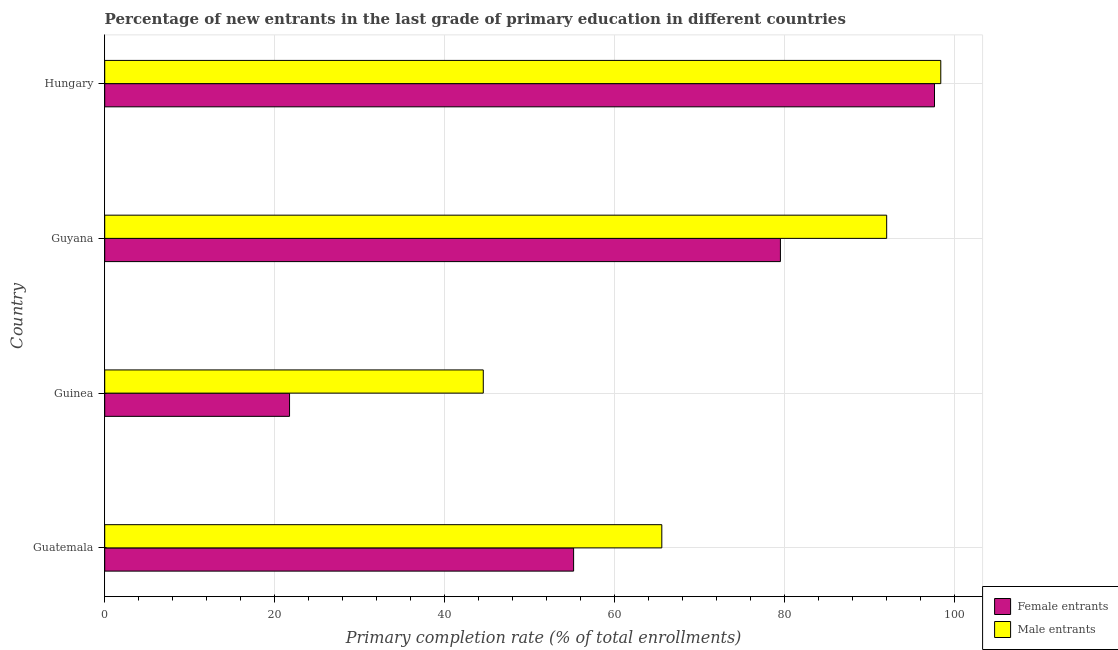How many different coloured bars are there?
Your answer should be compact. 2. Are the number of bars per tick equal to the number of legend labels?
Ensure brevity in your answer.  Yes. What is the label of the 1st group of bars from the top?
Ensure brevity in your answer.  Hungary. In how many cases, is the number of bars for a given country not equal to the number of legend labels?
Offer a very short reply. 0. What is the primary completion rate of female entrants in Guinea?
Your response must be concise. 21.75. Across all countries, what is the maximum primary completion rate of male entrants?
Offer a very short reply. 98.41. Across all countries, what is the minimum primary completion rate of female entrants?
Provide a short and direct response. 21.75. In which country was the primary completion rate of female entrants maximum?
Ensure brevity in your answer.  Hungary. In which country was the primary completion rate of male entrants minimum?
Make the answer very short. Guinea. What is the total primary completion rate of male entrants in the graph?
Offer a very short reply. 300.58. What is the difference between the primary completion rate of female entrants in Guatemala and that in Guinea?
Your answer should be very brief. 33.44. What is the difference between the primary completion rate of female entrants in Guatemala and the primary completion rate of male entrants in Guyana?
Make the answer very short. -36.85. What is the average primary completion rate of female entrants per country?
Offer a terse response. 63.54. What is the difference between the primary completion rate of male entrants and primary completion rate of female entrants in Hungary?
Provide a succinct answer. 0.74. What is the ratio of the primary completion rate of male entrants in Guinea to that in Hungary?
Give a very brief answer. 0.45. Is the difference between the primary completion rate of male entrants in Guyana and Hungary greater than the difference between the primary completion rate of female entrants in Guyana and Hungary?
Your answer should be compact. Yes. What is the difference between the highest and the second highest primary completion rate of male entrants?
Provide a succinct answer. 6.37. What is the difference between the highest and the lowest primary completion rate of male entrants?
Provide a succinct answer. 53.85. In how many countries, is the primary completion rate of female entrants greater than the average primary completion rate of female entrants taken over all countries?
Provide a short and direct response. 2. What does the 2nd bar from the top in Hungary represents?
Your answer should be compact. Female entrants. What does the 2nd bar from the bottom in Guyana represents?
Your answer should be very brief. Male entrants. What is the difference between two consecutive major ticks on the X-axis?
Provide a succinct answer. 20. Does the graph contain grids?
Offer a terse response. Yes. Where does the legend appear in the graph?
Give a very brief answer. Bottom right. How are the legend labels stacked?
Your response must be concise. Vertical. What is the title of the graph?
Offer a terse response. Percentage of new entrants in the last grade of primary education in different countries. Does "Attending school" appear as one of the legend labels in the graph?
Your response must be concise. No. What is the label or title of the X-axis?
Offer a very short reply. Primary completion rate (% of total enrollments). What is the Primary completion rate (% of total enrollments) of Female entrants in Guatemala?
Keep it short and to the point. 55.19. What is the Primary completion rate (% of total enrollments) of Male entrants in Guatemala?
Ensure brevity in your answer.  65.57. What is the Primary completion rate (% of total enrollments) in Female entrants in Guinea?
Provide a short and direct response. 21.75. What is the Primary completion rate (% of total enrollments) in Male entrants in Guinea?
Your answer should be compact. 44.56. What is the Primary completion rate (% of total enrollments) of Female entrants in Guyana?
Give a very brief answer. 79.53. What is the Primary completion rate (% of total enrollments) in Male entrants in Guyana?
Your answer should be compact. 92.04. What is the Primary completion rate (% of total enrollments) in Female entrants in Hungary?
Offer a terse response. 97.67. What is the Primary completion rate (% of total enrollments) in Male entrants in Hungary?
Offer a very short reply. 98.41. Across all countries, what is the maximum Primary completion rate (% of total enrollments) of Female entrants?
Your answer should be compact. 97.67. Across all countries, what is the maximum Primary completion rate (% of total enrollments) in Male entrants?
Provide a short and direct response. 98.41. Across all countries, what is the minimum Primary completion rate (% of total enrollments) in Female entrants?
Offer a terse response. 21.75. Across all countries, what is the minimum Primary completion rate (% of total enrollments) in Male entrants?
Offer a very short reply. 44.56. What is the total Primary completion rate (% of total enrollments) of Female entrants in the graph?
Provide a succinct answer. 254.15. What is the total Primary completion rate (% of total enrollments) of Male entrants in the graph?
Offer a terse response. 300.58. What is the difference between the Primary completion rate (% of total enrollments) of Female entrants in Guatemala and that in Guinea?
Your response must be concise. 33.44. What is the difference between the Primary completion rate (% of total enrollments) of Male entrants in Guatemala and that in Guinea?
Offer a terse response. 21.01. What is the difference between the Primary completion rate (% of total enrollments) in Female entrants in Guatemala and that in Guyana?
Your response must be concise. -24.34. What is the difference between the Primary completion rate (% of total enrollments) of Male entrants in Guatemala and that in Guyana?
Provide a short and direct response. -26.47. What is the difference between the Primary completion rate (% of total enrollments) in Female entrants in Guatemala and that in Hungary?
Offer a terse response. -42.48. What is the difference between the Primary completion rate (% of total enrollments) in Male entrants in Guatemala and that in Hungary?
Offer a very short reply. -32.84. What is the difference between the Primary completion rate (% of total enrollments) in Female entrants in Guinea and that in Guyana?
Offer a terse response. -57.78. What is the difference between the Primary completion rate (% of total enrollments) of Male entrants in Guinea and that in Guyana?
Offer a very short reply. -47.48. What is the difference between the Primary completion rate (% of total enrollments) of Female entrants in Guinea and that in Hungary?
Provide a short and direct response. -75.91. What is the difference between the Primary completion rate (% of total enrollments) in Male entrants in Guinea and that in Hungary?
Ensure brevity in your answer.  -53.85. What is the difference between the Primary completion rate (% of total enrollments) of Female entrants in Guyana and that in Hungary?
Offer a terse response. -18.14. What is the difference between the Primary completion rate (% of total enrollments) in Male entrants in Guyana and that in Hungary?
Your answer should be very brief. -6.37. What is the difference between the Primary completion rate (% of total enrollments) in Female entrants in Guatemala and the Primary completion rate (% of total enrollments) in Male entrants in Guinea?
Ensure brevity in your answer.  10.63. What is the difference between the Primary completion rate (% of total enrollments) of Female entrants in Guatemala and the Primary completion rate (% of total enrollments) of Male entrants in Guyana?
Your answer should be compact. -36.85. What is the difference between the Primary completion rate (% of total enrollments) in Female entrants in Guatemala and the Primary completion rate (% of total enrollments) in Male entrants in Hungary?
Your answer should be very brief. -43.22. What is the difference between the Primary completion rate (% of total enrollments) of Female entrants in Guinea and the Primary completion rate (% of total enrollments) of Male entrants in Guyana?
Provide a succinct answer. -70.29. What is the difference between the Primary completion rate (% of total enrollments) of Female entrants in Guinea and the Primary completion rate (% of total enrollments) of Male entrants in Hungary?
Give a very brief answer. -76.65. What is the difference between the Primary completion rate (% of total enrollments) in Female entrants in Guyana and the Primary completion rate (% of total enrollments) in Male entrants in Hungary?
Provide a short and direct response. -18.88. What is the average Primary completion rate (% of total enrollments) in Female entrants per country?
Give a very brief answer. 63.54. What is the average Primary completion rate (% of total enrollments) of Male entrants per country?
Give a very brief answer. 75.15. What is the difference between the Primary completion rate (% of total enrollments) of Female entrants and Primary completion rate (% of total enrollments) of Male entrants in Guatemala?
Your answer should be very brief. -10.38. What is the difference between the Primary completion rate (% of total enrollments) in Female entrants and Primary completion rate (% of total enrollments) in Male entrants in Guinea?
Ensure brevity in your answer.  -22.8. What is the difference between the Primary completion rate (% of total enrollments) in Female entrants and Primary completion rate (% of total enrollments) in Male entrants in Guyana?
Keep it short and to the point. -12.51. What is the difference between the Primary completion rate (% of total enrollments) of Female entrants and Primary completion rate (% of total enrollments) of Male entrants in Hungary?
Offer a terse response. -0.74. What is the ratio of the Primary completion rate (% of total enrollments) in Female entrants in Guatemala to that in Guinea?
Ensure brevity in your answer.  2.54. What is the ratio of the Primary completion rate (% of total enrollments) in Male entrants in Guatemala to that in Guinea?
Provide a short and direct response. 1.47. What is the ratio of the Primary completion rate (% of total enrollments) of Female entrants in Guatemala to that in Guyana?
Provide a short and direct response. 0.69. What is the ratio of the Primary completion rate (% of total enrollments) of Male entrants in Guatemala to that in Guyana?
Your response must be concise. 0.71. What is the ratio of the Primary completion rate (% of total enrollments) of Female entrants in Guatemala to that in Hungary?
Your response must be concise. 0.57. What is the ratio of the Primary completion rate (% of total enrollments) in Male entrants in Guatemala to that in Hungary?
Make the answer very short. 0.67. What is the ratio of the Primary completion rate (% of total enrollments) of Female entrants in Guinea to that in Guyana?
Give a very brief answer. 0.27. What is the ratio of the Primary completion rate (% of total enrollments) of Male entrants in Guinea to that in Guyana?
Keep it short and to the point. 0.48. What is the ratio of the Primary completion rate (% of total enrollments) in Female entrants in Guinea to that in Hungary?
Provide a succinct answer. 0.22. What is the ratio of the Primary completion rate (% of total enrollments) in Male entrants in Guinea to that in Hungary?
Your response must be concise. 0.45. What is the ratio of the Primary completion rate (% of total enrollments) of Female entrants in Guyana to that in Hungary?
Offer a terse response. 0.81. What is the ratio of the Primary completion rate (% of total enrollments) in Male entrants in Guyana to that in Hungary?
Provide a succinct answer. 0.94. What is the difference between the highest and the second highest Primary completion rate (% of total enrollments) in Female entrants?
Offer a terse response. 18.14. What is the difference between the highest and the second highest Primary completion rate (% of total enrollments) in Male entrants?
Offer a terse response. 6.37. What is the difference between the highest and the lowest Primary completion rate (% of total enrollments) of Female entrants?
Give a very brief answer. 75.91. What is the difference between the highest and the lowest Primary completion rate (% of total enrollments) in Male entrants?
Provide a succinct answer. 53.85. 